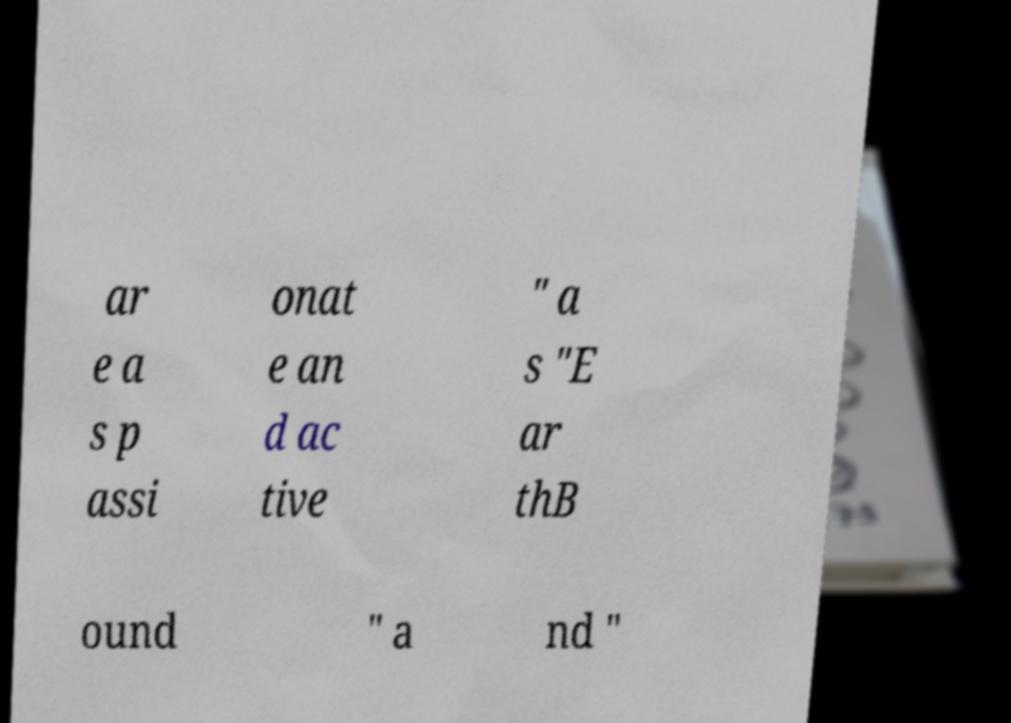Could you assist in decoding the text presented in this image and type it out clearly? ar e a s p assi onat e an d ac tive " a s "E ar thB ound " a nd " 